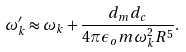<formula> <loc_0><loc_0><loc_500><loc_500>\omega _ { k } ^ { \prime } \approx \omega _ { k } + \frac { d _ { m } d _ { c } } { 4 \pi \epsilon _ { o } m \omega _ { k } ^ { 2 } R ^ { 5 } } .</formula> 